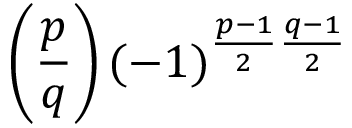<formula> <loc_0><loc_0><loc_500><loc_500>\left ( { \frac { p } { q } } \right ) ( - 1 ) ^ { { \frac { p - 1 } { 2 } } { \frac { q - 1 } { 2 } } }</formula> 